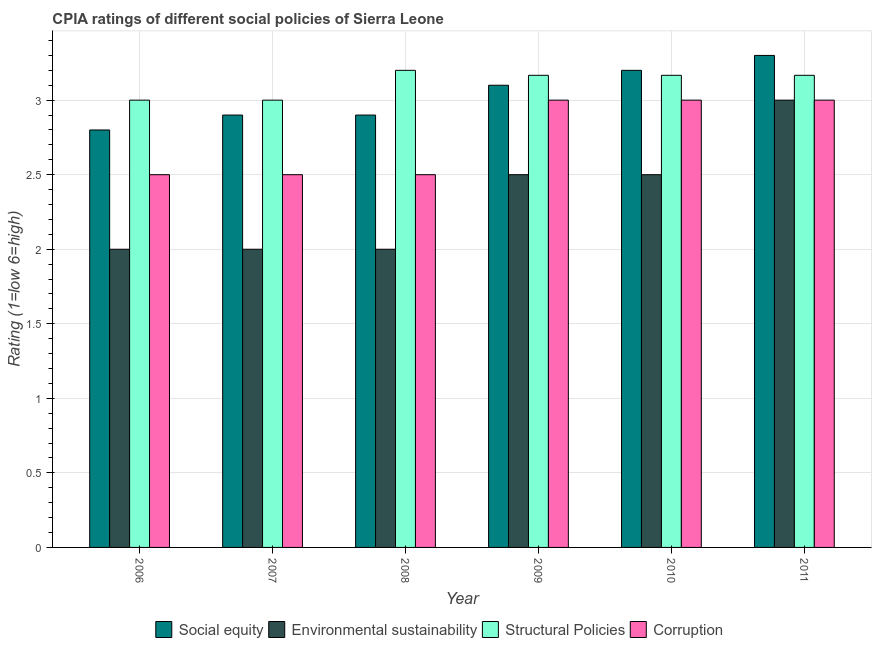How many groups of bars are there?
Offer a very short reply. 6. Are the number of bars per tick equal to the number of legend labels?
Make the answer very short. Yes. In how many cases, is the number of bars for a given year not equal to the number of legend labels?
Keep it short and to the point. 0. What is the cpia rating of environmental sustainability in 2009?
Keep it short and to the point. 2.5. In which year was the cpia rating of structural policies minimum?
Provide a short and direct response. 2006. What is the average cpia rating of social equity per year?
Provide a short and direct response. 3.03. What is the ratio of the cpia rating of structural policies in 2006 to that in 2009?
Your answer should be compact. 0.95. Is the cpia rating of corruption in 2006 less than that in 2009?
Ensure brevity in your answer.  Yes. What is the difference between the highest and the second highest cpia rating of social equity?
Provide a succinct answer. 0.1. In how many years, is the cpia rating of environmental sustainability greater than the average cpia rating of environmental sustainability taken over all years?
Ensure brevity in your answer.  3. What does the 3rd bar from the left in 2008 represents?
Make the answer very short. Structural Policies. What does the 2nd bar from the right in 2006 represents?
Provide a short and direct response. Structural Policies. How many bars are there?
Your answer should be compact. 24. How many years are there in the graph?
Give a very brief answer. 6. How many legend labels are there?
Your answer should be very brief. 4. How are the legend labels stacked?
Keep it short and to the point. Horizontal. What is the title of the graph?
Your response must be concise. CPIA ratings of different social policies of Sierra Leone. What is the label or title of the X-axis?
Your response must be concise. Year. What is the Rating (1=low 6=high) of Environmental sustainability in 2006?
Provide a succinct answer. 2. What is the Rating (1=low 6=high) in Structural Policies in 2006?
Offer a very short reply. 3. What is the Rating (1=low 6=high) of Corruption in 2006?
Offer a very short reply. 2.5. What is the Rating (1=low 6=high) in Environmental sustainability in 2007?
Your response must be concise. 2. What is the Rating (1=low 6=high) of Structural Policies in 2007?
Provide a succinct answer. 3. What is the Rating (1=low 6=high) of Environmental sustainability in 2008?
Make the answer very short. 2. What is the Rating (1=low 6=high) of Structural Policies in 2009?
Offer a very short reply. 3.17. What is the Rating (1=low 6=high) in Social equity in 2010?
Provide a short and direct response. 3.2. What is the Rating (1=low 6=high) in Structural Policies in 2010?
Give a very brief answer. 3.17. What is the Rating (1=low 6=high) in Social equity in 2011?
Provide a short and direct response. 3.3. What is the Rating (1=low 6=high) in Environmental sustainability in 2011?
Keep it short and to the point. 3. What is the Rating (1=low 6=high) in Structural Policies in 2011?
Your answer should be very brief. 3.17. Across all years, what is the maximum Rating (1=low 6=high) in Social equity?
Your answer should be very brief. 3.3. Across all years, what is the minimum Rating (1=low 6=high) in Structural Policies?
Offer a very short reply. 3. Across all years, what is the minimum Rating (1=low 6=high) in Corruption?
Give a very brief answer. 2.5. What is the total Rating (1=low 6=high) of Social equity in the graph?
Provide a succinct answer. 18.2. What is the total Rating (1=low 6=high) of Structural Policies in the graph?
Your answer should be compact. 18.7. What is the difference between the Rating (1=low 6=high) in Social equity in 2006 and that in 2007?
Your answer should be compact. -0.1. What is the difference between the Rating (1=low 6=high) of Environmental sustainability in 2006 and that in 2007?
Your response must be concise. 0. What is the difference between the Rating (1=low 6=high) in Structural Policies in 2006 and that in 2007?
Offer a very short reply. 0. What is the difference between the Rating (1=low 6=high) of Corruption in 2006 and that in 2007?
Offer a very short reply. 0. What is the difference between the Rating (1=low 6=high) in Social equity in 2006 and that in 2008?
Your answer should be very brief. -0.1. What is the difference between the Rating (1=low 6=high) in Corruption in 2006 and that in 2009?
Offer a terse response. -0.5. What is the difference between the Rating (1=low 6=high) of Social equity in 2006 and that in 2010?
Make the answer very short. -0.4. What is the difference between the Rating (1=low 6=high) of Environmental sustainability in 2006 and that in 2010?
Offer a very short reply. -0.5. What is the difference between the Rating (1=low 6=high) of Structural Policies in 2006 and that in 2010?
Offer a terse response. -0.17. What is the difference between the Rating (1=low 6=high) in Corruption in 2006 and that in 2010?
Keep it short and to the point. -0.5. What is the difference between the Rating (1=low 6=high) of Social equity in 2006 and that in 2011?
Keep it short and to the point. -0.5. What is the difference between the Rating (1=low 6=high) in Environmental sustainability in 2006 and that in 2011?
Your response must be concise. -1. What is the difference between the Rating (1=low 6=high) in Environmental sustainability in 2007 and that in 2008?
Provide a short and direct response. 0. What is the difference between the Rating (1=low 6=high) in Corruption in 2007 and that in 2008?
Your response must be concise. 0. What is the difference between the Rating (1=low 6=high) of Social equity in 2007 and that in 2009?
Give a very brief answer. -0.2. What is the difference between the Rating (1=low 6=high) of Environmental sustainability in 2007 and that in 2009?
Offer a very short reply. -0.5. What is the difference between the Rating (1=low 6=high) of Structural Policies in 2007 and that in 2009?
Provide a succinct answer. -0.17. What is the difference between the Rating (1=low 6=high) in Corruption in 2007 and that in 2009?
Offer a terse response. -0.5. What is the difference between the Rating (1=low 6=high) of Environmental sustainability in 2007 and that in 2011?
Give a very brief answer. -1. What is the difference between the Rating (1=low 6=high) of Corruption in 2007 and that in 2011?
Your answer should be compact. -0.5. What is the difference between the Rating (1=low 6=high) of Social equity in 2008 and that in 2009?
Your answer should be very brief. -0.2. What is the difference between the Rating (1=low 6=high) of Structural Policies in 2008 and that in 2009?
Provide a short and direct response. 0.03. What is the difference between the Rating (1=low 6=high) in Corruption in 2008 and that in 2009?
Ensure brevity in your answer.  -0.5. What is the difference between the Rating (1=low 6=high) of Environmental sustainability in 2008 and that in 2010?
Offer a terse response. -0.5. What is the difference between the Rating (1=low 6=high) of Structural Policies in 2008 and that in 2010?
Keep it short and to the point. 0.03. What is the difference between the Rating (1=low 6=high) of Structural Policies in 2008 and that in 2011?
Provide a short and direct response. 0.03. What is the difference between the Rating (1=low 6=high) of Social equity in 2009 and that in 2010?
Offer a terse response. -0.1. What is the difference between the Rating (1=low 6=high) in Environmental sustainability in 2009 and that in 2010?
Your answer should be very brief. 0. What is the difference between the Rating (1=low 6=high) of Structural Policies in 2009 and that in 2010?
Offer a terse response. 0. What is the difference between the Rating (1=low 6=high) in Corruption in 2009 and that in 2010?
Your answer should be compact. 0. What is the difference between the Rating (1=low 6=high) in Environmental sustainability in 2009 and that in 2011?
Make the answer very short. -0.5. What is the difference between the Rating (1=low 6=high) in Social equity in 2010 and that in 2011?
Your response must be concise. -0.1. What is the difference between the Rating (1=low 6=high) of Structural Policies in 2010 and that in 2011?
Give a very brief answer. 0. What is the difference between the Rating (1=low 6=high) in Corruption in 2010 and that in 2011?
Make the answer very short. 0. What is the difference between the Rating (1=low 6=high) of Social equity in 2006 and the Rating (1=low 6=high) of Environmental sustainability in 2007?
Provide a short and direct response. 0.8. What is the difference between the Rating (1=low 6=high) in Social equity in 2006 and the Rating (1=low 6=high) in Structural Policies in 2007?
Your answer should be compact. -0.2. What is the difference between the Rating (1=low 6=high) of Social equity in 2006 and the Rating (1=low 6=high) of Corruption in 2007?
Offer a very short reply. 0.3. What is the difference between the Rating (1=low 6=high) of Environmental sustainability in 2006 and the Rating (1=low 6=high) of Structural Policies in 2007?
Give a very brief answer. -1. What is the difference between the Rating (1=low 6=high) of Social equity in 2006 and the Rating (1=low 6=high) of Environmental sustainability in 2008?
Give a very brief answer. 0.8. What is the difference between the Rating (1=low 6=high) in Environmental sustainability in 2006 and the Rating (1=low 6=high) in Structural Policies in 2008?
Your answer should be compact. -1.2. What is the difference between the Rating (1=low 6=high) in Structural Policies in 2006 and the Rating (1=low 6=high) in Corruption in 2008?
Your answer should be very brief. 0.5. What is the difference between the Rating (1=low 6=high) of Social equity in 2006 and the Rating (1=low 6=high) of Environmental sustainability in 2009?
Your answer should be compact. 0.3. What is the difference between the Rating (1=low 6=high) in Social equity in 2006 and the Rating (1=low 6=high) in Structural Policies in 2009?
Offer a terse response. -0.37. What is the difference between the Rating (1=low 6=high) in Social equity in 2006 and the Rating (1=low 6=high) in Corruption in 2009?
Your answer should be compact. -0.2. What is the difference between the Rating (1=low 6=high) of Environmental sustainability in 2006 and the Rating (1=low 6=high) of Structural Policies in 2009?
Provide a succinct answer. -1.17. What is the difference between the Rating (1=low 6=high) in Social equity in 2006 and the Rating (1=low 6=high) in Structural Policies in 2010?
Make the answer very short. -0.37. What is the difference between the Rating (1=low 6=high) of Environmental sustainability in 2006 and the Rating (1=low 6=high) of Structural Policies in 2010?
Your answer should be compact. -1.17. What is the difference between the Rating (1=low 6=high) in Structural Policies in 2006 and the Rating (1=low 6=high) in Corruption in 2010?
Provide a short and direct response. 0. What is the difference between the Rating (1=low 6=high) of Social equity in 2006 and the Rating (1=low 6=high) of Structural Policies in 2011?
Keep it short and to the point. -0.37. What is the difference between the Rating (1=low 6=high) of Environmental sustainability in 2006 and the Rating (1=low 6=high) of Structural Policies in 2011?
Make the answer very short. -1.17. What is the difference between the Rating (1=low 6=high) in Environmental sustainability in 2006 and the Rating (1=low 6=high) in Corruption in 2011?
Provide a succinct answer. -1. What is the difference between the Rating (1=low 6=high) of Social equity in 2007 and the Rating (1=low 6=high) of Structural Policies in 2008?
Give a very brief answer. -0.3. What is the difference between the Rating (1=low 6=high) of Social equity in 2007 and the Rating (1=low 6=high) of Corruption in 2008?
Offer a terse response. 0.4. What is the difference between the Rating (1=low 6=high) in Environmental sustainability in 2007 and the Rating (1=low 6=high) in Structural Policies in 2008?
Provide a short and direct response. -1.2. What is the difference between the Rating (1=low 6=high) of Environmental sustainability in 2007 and the Rating (1=low 6=high) of Corruption in 2008?
Keep it short and to the point. -0.5. What is the difference between the Rating (1=low 6=high) of Social equity in 2007 and the Rating (1=low 6=high) of Structural Policies in 2009?
Give a very brief answer. -0.27. What is the difference between the Rating (1=low 6=high) in Social equity in 2007 and the Rating (1=low 6=high) in Corruption in 2009?
Make the answer very short. -0.1. What is the difference between the Rating (1=low 6=high) of Environmental sustainability in 2007 and the Rating (1=low 6=high) of Structural Policies in 2009?
Your answer should be very brief. -1.17. What is the difference between the Rating (1=low 6=high) of Social equity in 2007 and the Rating (1=low 6=high) of Structural Policies in 2010?
Provide a short and direct response. -0.27. What is the difference between the Rating (1=low 6=high) of Social equity in 2007 and the Rating (1=low 6=high) of Corruption in 2010?
Provide a succinct answer. -0.1. What is the difference between the Rating (1=low 6=high) in Environmental sustainability in 2007 and the Rating (1=low 6=high) in Structural Policies in 2010?
Provide a succinct answer. -1.17. What is the difference between the Rating (1=low 6=high) in Environmental sustainability in 2007 and the Rating (1=low 6=high) in Corruption in 2010?
Offer a terse response. -1. What is the difference between the Rating (1=low 6=high) of Social equity in 2007 and the Rating (1=low 6=high) of Structural Policies in 2011?
Offer a terse response. -0.27. What is the difference between the Rating (1=low 6=high) in Social equity in 2007 and the Rating (1=low 6=high) in Corruption in 2011?
Your response must be concise. -0.1. What is the difference between the Rating (1=low 6=high) in Environmental sustainability in 2007 and the Rating (1=low 6=high) in Structural Policies in 2011?
Your answer should be compact. -1.17. What is the difference between the Rating (1=low 6=high) in Social equity in 2008 and the Rating (1=low 6=high) in Environmental sustainability in 2009?
Keep it short and to the point. 0.4. What is the difference between the Rating (1=low 6=high) of Social equity in 2008 and the Rating (1=low 6=high) of Structural Policies in 2009?
Your response must be concise. -0.27. What is the difference between the Rating (1=low 6=high) in Environmental sustainability in 2008 and the Rating (1=low 6=high) in Structural Policies in 2009?
Offer a terse response. -1.17. What is the difference between the Rating (1=low 6=high) of Social equity in 2008 and the Rating (1=low 6=high) of Structural Policies in 2010?
Provide a succinct answer. -0.27. What is the difference between the Rating (1=low 6=high) of Social equity in 2008 and the Rating (1=low 6=high) of Corruption in 2010?
Your answer should be very brief. -0.1. What is the difference between the Rating (1=low 6=high) in Environmental sustainability in 2008 and the Rating (1=low 6=high) in Structural Policies in 2010?
Ensure brevity in your answer.  -1.17. What is the difference between the Rating (1=low 6=high) in Structural Policies in 2008 and the Rating (1=low 6=high) in Corruption in 2010?
Give a very brief answer. 0.2. What is the difference between the Rating (1=low 6=high) of Social equity in 2008 and the Rating (1=low 6=high) of Structural Policies in 2011?
Provide a succinct answer. -0.27. What is the difference between the Rating (1=low 6=high) of Environmental sustainability in 2008 and the Rating (1=low 6=high) of Structural Policies in 2011?
Offer a terse response. -1.17. What is the difference between the Rating (1=low 6=high) of Social equity in 2009 and the Rating (1=low 6=high) of Environmental sustainability in 2010?
Your answer should be very brief. 0.6. What is the difference between the Rating (1=low 6=high) of Social equity in 2009 and the Rating (1=low 6=high) of Structural Policies in 2010?
Provide a succinct answer. -0.07. What is the difference between the Rating (1=low 6=high) of Structural Policies in 2009 and the Rating (1=low 6=high) of Corruption in 2010?
Offer a very short reply. 0.17. What is the difference between the Rating (1=low 6=high) of Social equity in 2009 and the Rating (1=low 6=high) of Structural Policies in 2011?
Provide a short and direct response. -0.07. What is the difference between the Rating (1=low 6=high) in Social equity in 2010 and the Rating (1=low 6=high) in Environmental sustainability in 2011?
Provide a short and direct response. 0.2. What is the difference between the Rating (1=low 6=high) in Environmental sustainability in 2010 and the Rating (1=low 6=high) in Structural Policies in 2011?
Make the answer very short. -0.67. What is the difference between the Rating (1=low 6=high) in Environmental sustainability in 2010 and the Rating (1=low 6=high) in Corruption in 2011?
Offer a terse response. -0.5. What is the average Rating (1=low 6=high) in Social equity per year?
Give a very brief answer. 3.03. What is the average Rating (1=low 6=high) in Environmental sustainability per year?
Offer a terse response. 2.33. What is the average Rating (1=low 6=high) of Structural Policies per year?
Your answer should be compact. 3.12. What is the average Rating (1=low 6=high) in Corruption per year?
Make the answer very short. 2.75. In the year 2006, what is the difference between the Rating (1=low 6=high) in Social equity and Rating (1=low 6=high) in Environmental sustainability?
Your answer should be very brief. 0.8. In the year 2006, what is the difference between the Rating (1=low 6=high) of Social equity and Rating (1=low 6=high) of Corruption?
Provide a succinct answer. 0.3. In the year 2006, what is the difference between the Rating (1=low 6=high) in Structural Policies and Rating (1=low 6=high) in Corruption?
Provide a short and direct response. 0.5. In the year 2007, what is the difference between the Rating (1=low 6=high) of Environmental sustainability and Rating (1=low 6=high) of Structural Policies?
Your response must be concise. -1. In the year 2007, what is the difference between the Rating (1=low 6=high) in Environmental sustainability and Rating (1=low 6=high) in Corruption?
Your response must be concise. -0.5. In the year 2007, what is the difference between the Rating (1=low 6=high) in Structural Policies and Rating (1=low 6=high) in Corruption?
Your answer should be very brief. 0.5. In the year 2008, what is the difference between the Rating (1=low 6=high) in Social equity and Rating (1=low 6=high) in Corruption?
Provide a short and direct response. 0.4. In the year 2008, what is the difference between the Rating (1=low 6=high) in Environmental sustainability and Rating (1=low 6=high) in Structural Policies?
Your answer should be compact. -1.2. In the year 2009, what is the difference between the Rating (1=low 6=high) in Social equity and Rating (1=low 6=high) in Structural Policies?
Keep it short and to the point. -0.07. In the year 2009, what is the difference between the Rating (1=low 6=high) of Environmental sustainability and Rating (1=low 6=high) of Corruption?
Keep it short and to the point. -0.5. In the year 2010, what is the difference between the Rating (1=low 6=high) in Social equity and Rating (1=low 6=high) in Environmental sustainability?
Ensure brevity in your answer.  0.7. In the year 2010, what is the difference between the Rating (1=low 6=high) of Social equity and Rating (1=low 6=high) of Structural Policies?
Make the answer very short. 0.03. In the year 2010, what is the difference between the Rating (1=low 6=high) in Environmental sustainability and Rating (1=low 6=high) in Corruption?
Make the answer very short. -0.5. In the year 2011, what is the difference between the Rating (1=low 6=high) of Social equity and Rating (1=low 6=high) of Structural Policies?
Keep it short and to the point. 0.13. What is the ratio of the Rating (1=low 6=high) of Social equity in 2006 to that in 2007?
Ensure brevity in your answer.  0.97. What is the ratio of the Rating (1=low 6=high) in Corruption in 2006 to that in 2007?
Offer a very short reply. 1. What is the ratio of the Rating (1=low 6=high) in Social equity in 2006 to that in 2008?
Give a very brief answer. 0.97. What is the ratio of the Rating (1=low 6=high) of Social equity in 2006 to that in 2009?
Your answer should be very brief. 0.9. What is the ratio of the Rating (1=low 6=high) of Corruption in 2006 to that in 2009?
Give a very brief answer. 0.83. What is the ratio of the Rating (1=low 6=high) in Social equity in 2006 to that in 2010?
Give a very brief answer. 0.88. What is the ratio of the Rating (1=low 6=high) of Environmental sustainability in 2006 to that in 2010?
Offer a very short reply. 0.8. What is the ratio of the Rating (1=low 6=high) in Social equity in 2006 to that in 2011?
Keep it short and to the point. 0.85. What is the ratio of the Rating (1=low 6=high) of Corruption in 2006 to that in 2011?
Give a very brief answer. 0.83. What is the ratio of the Rating (1=low 6=high) in Social equity in 2007 to that in 2008?
Provide a short and direct response. 1. What is the ratio of the Rating (1=low 6=high) of Corruption in 2007 to that in 2008?
Give a very brief answer. 1. What is the ratio of the Rating (1=low 6=high) of Social equity in 2007 to that in 2009?
Offer a terse response. 0.94. What is the ratio of the Rating (1=low 6=high) of Social equity in 2007 to that in 2010?
Ensure brevity in your answer.  0.91. What is the ratio of the Rating (1=low 6=high) of Social equity in 2007 to that in 2011?
Keep it short and to the point. 0.88. What is the ratio of the Rating (1=low 6=high) of Environmental sustainability in 2007 to that in 2011?
Make the answer very short. 0.67. What is the ratio of the Rating (1=low 6=high) in Social equity in 2008 to that in 2009?
Give a very brief answer. 0.94. What is the ratio of the Rating (1=low 6=high) in Structural Policies in 2008 to that in 2009?
Give a very brief answer. 1.01. What is the ratio of the Rating (1=low 6=high) of Social equity in 2008 to that in 2010?
Offer a very short reply. 0.91. What is the ratio of the Rating (1=low 6=high) of Structural Policies in 2008 to that in 2010?
Your answer should be compact. 1.01. What is the ratio of the Rating (1=low 6=high) of Social equity in 2008 to that in 2011?
Keep it short and to the point. 0.88. What is the ratio of the Rating (1=low 6=high) in Environmental sustainability in 2008 to that in 2011?
Your answer should be compact. 0.67. What is the ratio of the Rating (1=low 6=high) of Structural Policies in 2008 to that in 2011?
Give a very brief answer. 1.01. What is the ratio of the Rating (1=low 6=high) of Corruption in 2008 to that in 2011?
Provide a succinct answer. 0.83. What is the ratio of the Rating (1=low 6=high) in Social equity in 2009 to that in 2010?
Ensure brevity in your answer.  0.97. What is the ratio of the Rating (1=low 6=high) in Corruption in 2009 to that in 2010?
Your answer should be very brief. 1. What is the ratio of the Rating (1=low 6=high) in Social equity in 2009 to that in 2011?
Your answer should be compact. 0.94. What is the ratio of the Rating (1=low 6=high) in Structural Policies in 2009 to that in 2011?
Your answer should be compact. 1. What is the ratio of the Rating (1=low 6=high) in Corruption in 2009 to that in 2011?
Provide a short and direct response. 1. What is the ratio of the Rating (1=low 6=high) of Social equity in 2010 to that in 2011?
Your answer should be very brief. 0.97. What is the difference between the highest and the second highest Rating (1=low 6=high) in Social equity?
Your answer should be very brief. 0.1. What is the difference between the highest and the second highest Rating (1=low 6=high) of Environmental sustainability?
Ensure brevity in your answer.  0.5. What is the difference between the highest and the second highest Rating (1=low 6=high) in Structural Policies?
Offer a terse response. 0.03. What is the difference between the highest and the second highest Rating (1=low 6=high) of Corruption?
Your response must be concise. 0. What is the difference between the highest and the lowest Rating (1=low 6=high) of Environmental sustainability?
Your response must be concise. 1. What is the difference between the highest and the lowest Rating (1=low 6=high) in Structural Policies?
Your answer should be very brief. 0.2. 